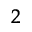Convert formula to latex. <formula><loc_0><loc_0><loc_500><loc_500>^ { 2 }</formula> 